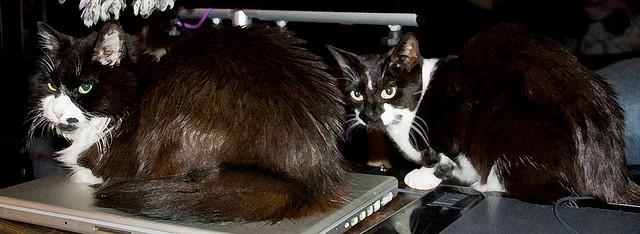What is on top of the laptop?
Concise answer only. Cat. How many cats are there?
Give a very brief answer. 2. What is the main color of the animals coat?
Give a very brief answer. Black. 